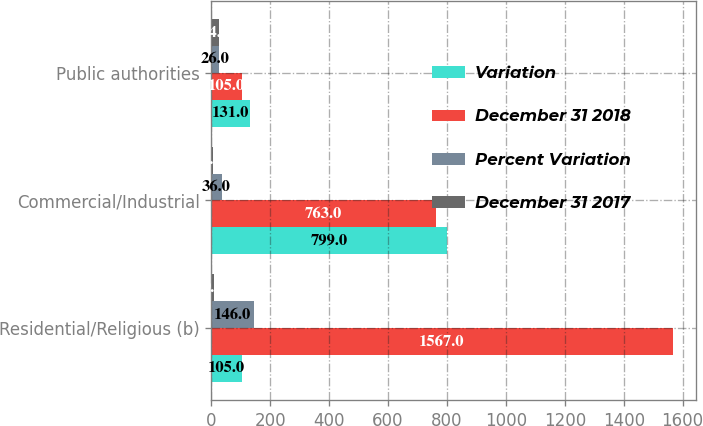Convert chart to OTSL. <chart><loc_0><loc_0><loc_500><loc_500><stacked_bar_chart><ecel><fcel>Residential/Religious (b)<fcel>Commercial/Industrial<fcel>Public authorities<nl><fcel>Variation<fcel>105<fcel>799<fcel>131<nl><fcel>December 31 2018<fcel>1567<fcel>763<fcel>105<nl><fcel>Percent Variation<fcel>146<fcel>36<fcel>26<nl><fcel>December 31 2017<fcel>9.3<fcel>4.7<fcel>24.8<nl></chart> 